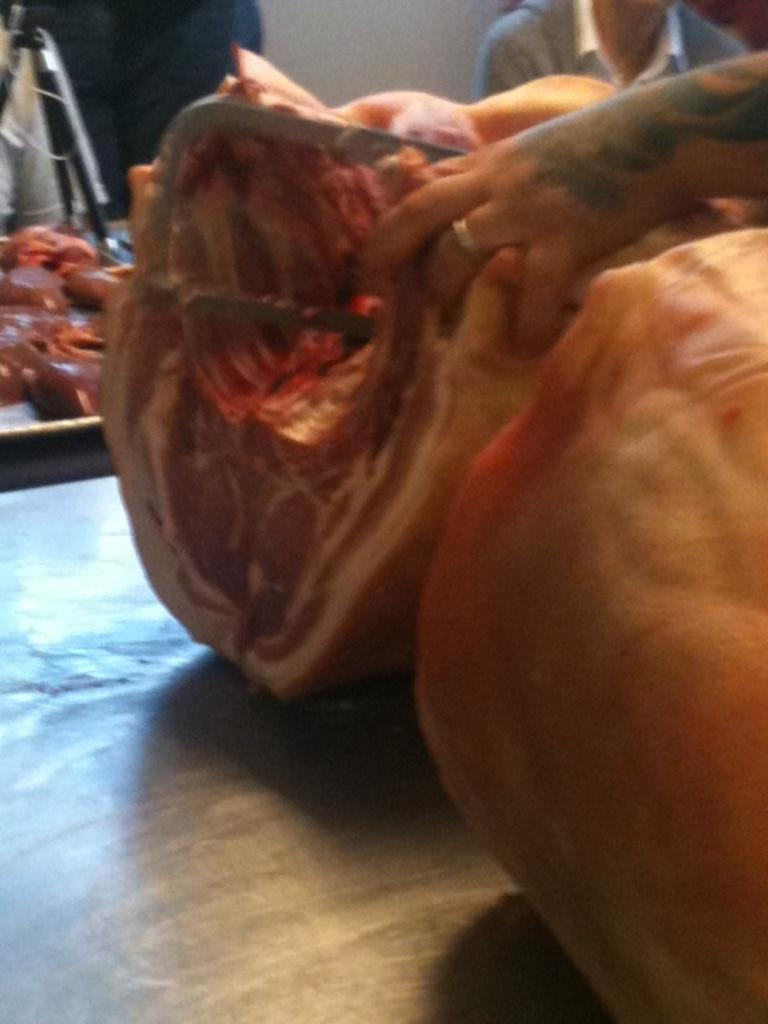What is the main subject in the front of the image? There is a person's hand in the front of the image. What can be observed about the hand's appearance? The hand has flesh visible. Can you describe the background of the image? There is another person in the background of the image. What type of scent can be detected coming from the hand in the image? There is no indication of a scent in the image, as it only shows a person's hand with visible flesh. 